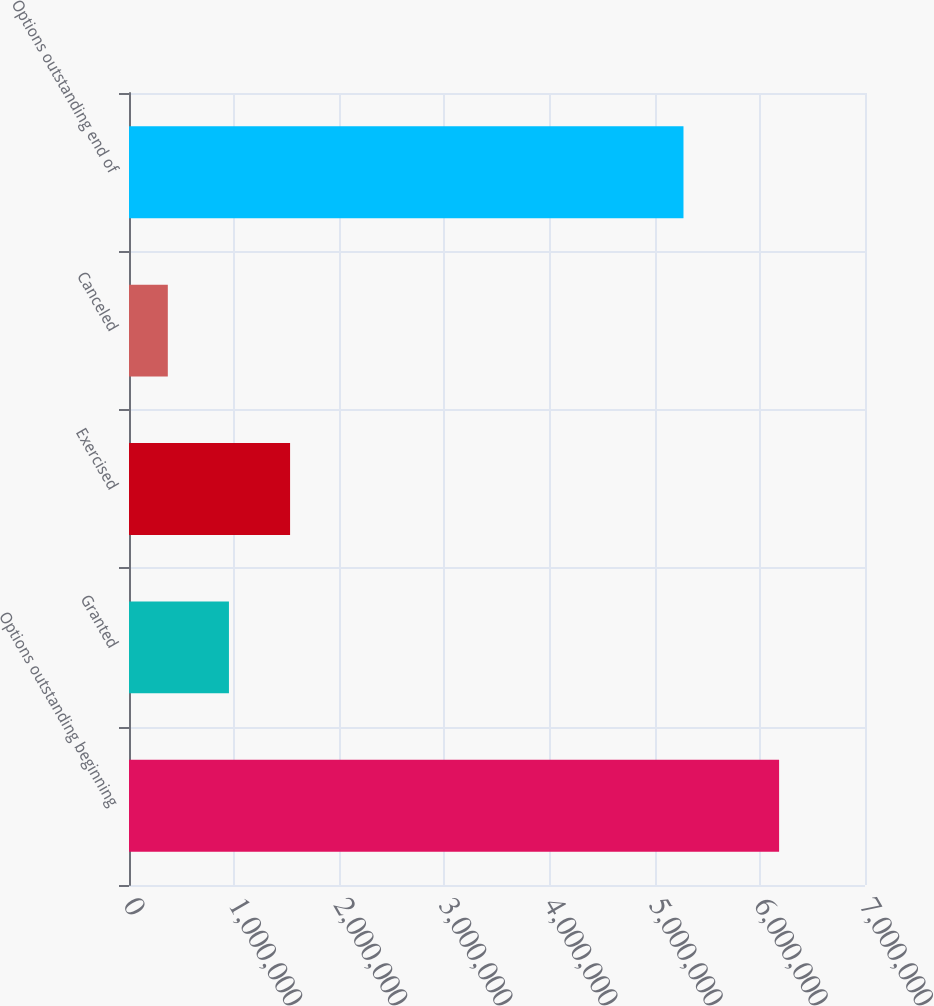Convert chart. <chart><loc_0><loc_0><loc_500><loc_500><bar_chart><fcel>Options outstanding beginning<fcel>Granted<fcel>Exercised<fcel>Canceled<fcel>Options outstanding end of<nl><fcel>6.18302e+06<fcel>950583<fcel>1.53196e+06<fcel>369202<fcel>5.27357e+06<nl></chart> 